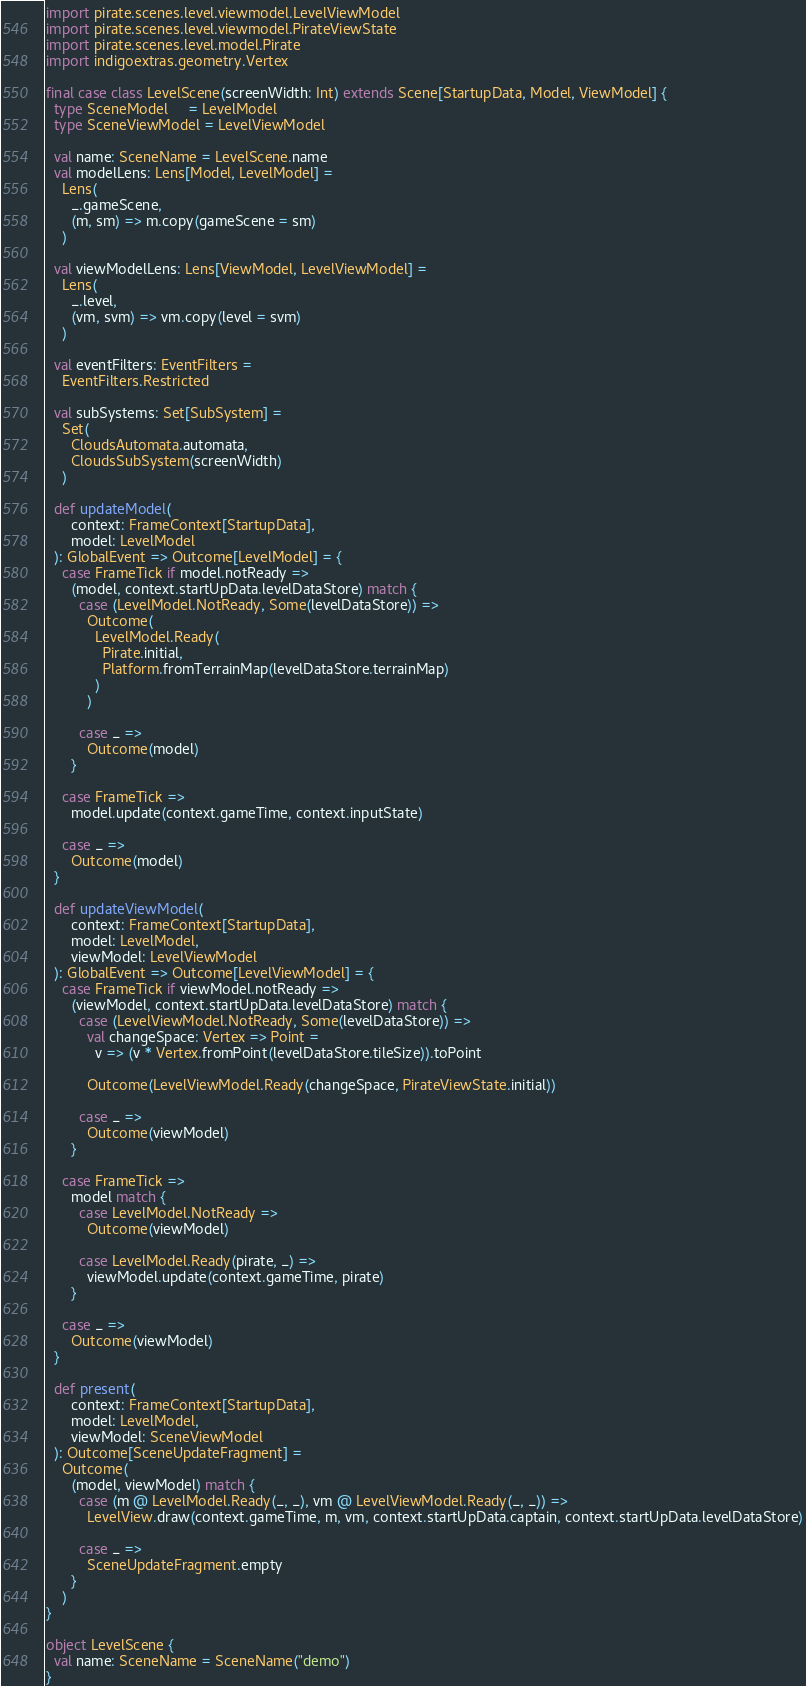Convert code to text. <code><loc_0><loc_0><loc_500><loc_500><_Scala_>import pirate.scenes.level.viewmodel.LevelViewModel
import pirate.scenes.level.viewmodel.PirateViewState
import pirate.scenes.level.model.Pirate
import indigoextras.geometry.Vertex

final case class LevelScene(screenWidth: Int) extends Scene[StartupData, Model, ViewModel] {
  type SceneModel     = LevelModel
  type SceneViewModel = LevelViewModel

  val name: SceneName = LevelScene.name
  val modelLens: Lens[Model, LevelModel] =
    Lens(
      _.gameScene,
      (m, sm) => m.copy(gameScene = sm)
    )

  val viewModelLens: Lens[ViewModel, LevelViewModel] =
    Lens(
      _.level,
      (vm, svm) => vm.copy(level = svm)
    )

  val eventFilters: EventFilters =
    EventFilters.Restricted

  val subSystems: Set[SubSystem] =
    Set(
      CloudsAutomata.automata,
      CloudsSubSystem(screenWidth)
    )

  def updateModel(
      context: FrameContext[StartupData],
      model: LevelModel
  ): GlobalEvent => Outcome[LevelModel] = {
    case FrameTick if model.notReady =>
      (model, context.startUpData.levelDataStore) match {
        case (LevelModel.NotReady, Some(levelDataStore)) =>
          Outcome(
            LevelModel.Ready(
              Pirate.initial,
              Platform.fromTerrainMap(levelDataStore.terrainMap)
            )
          )

        case _ =>
          Outcome(model)
      }

    case FrameTick =>
      model.update(context.gameTime, context.inputState)

    case _ =>
      Outcome(model)
  }

  def updateViewModel(
      context: FrameContext[StartupData],
      model: LevelModel,
      viewModel: LevelViewModel
  ): GlobalEvent => Outcome[LevelViewModel] = {
    case FrameTick if viewModel.notReady =>
      (viewModel, context.startUpData.levelDataStore) match {
        case (LevelViewModel.NotReady, Some(levelDataStore)) =>
          val changeSpace: Vertex => Point =
            v => (v * Vertex.fromPoint(levelDataStore.tileSize)).toPoint

          Outcome(LevelViewModel.Ready(changeSpace, PirateViewState.initial))

        case _ =>
          Outcome(viewModel)
      }

    case FrameTick =>
      model match {
        case LevelModel.NotReady =>
          Outcome(viewModel)

        case LevelModel.Ready(pirate, _) =>
          viewModel.update(context.gameTime, pirate)
      }

    case _ =>
      Outcome(viewModel)
  }

  def present(
      context: FrameContext[StartupData],
      model: LevelModel,
      viewModel: SceneViewModel
  ): Outcome[SceneUpdateFragment] =
    Outcome(
      (model, viewModel) match {
        case (m @ LevelModel.Ready(_, _), vm @ LevelViewModel.Ready(_, _)) =>
          LevelView.draw(context.gameTime, m, vm, context.startUpData.captain, context.startUpData.levelDataStore)

        case _ =>
          SceneUpdateFragment.empty
      }
    )
}

object LevelScene {
  val name: SceneName = SceneName("demo")
}
</code> 